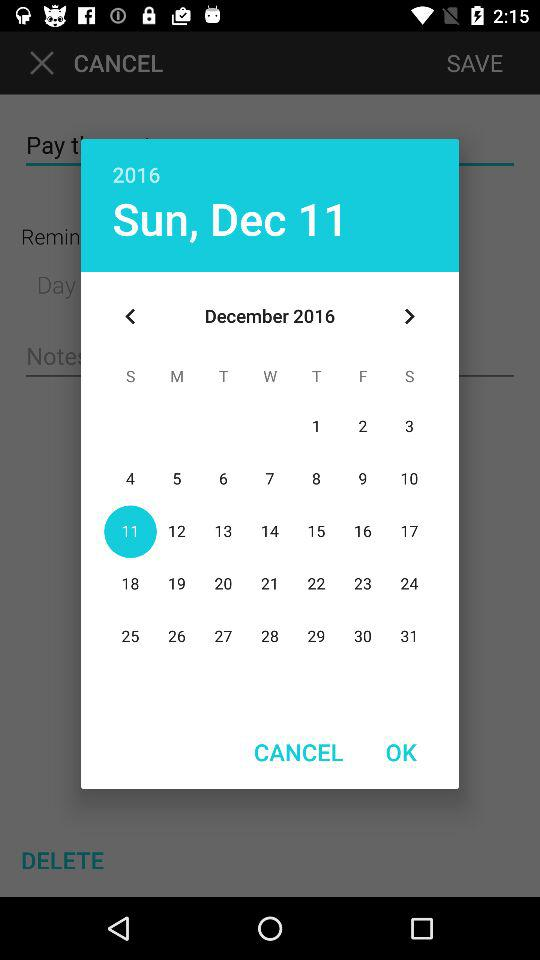What day comes on December 11? The day is Sunday. 